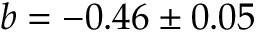Convert formula to latex. <formula><loc_0><loc_0><loc_500><loc_500>b = - 0 . 4 6 \pm 0 . 0 5</formula> 